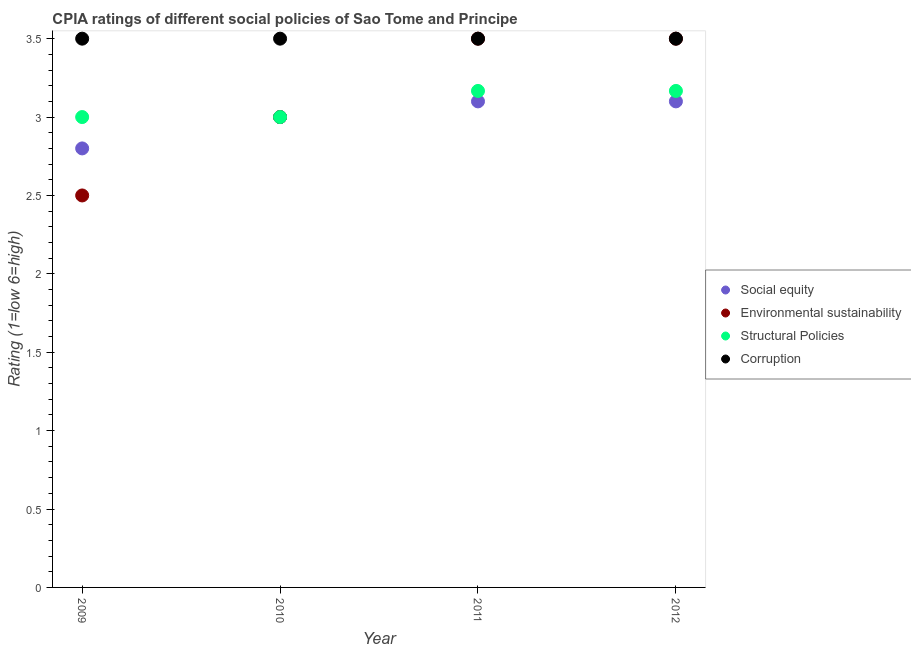How many different coloured dotlines are there?
Make the answer very short. 4. What is the cpia rating of structural policies in 2012?
Provide a succinct answer. 3.17. In which year was the cpia rating of corruption maximum?
Offer a terse response. 2009. In which year was the cpia rating of environmental sustainability minimum?
Ensure brevity in your answer.  2009. What is the total cpia rating of corruption in the graph?
Provide a short and direct response. 14. What is the difference between the cpia rating of environmental sustainability in 2010 and the cpia rating of corruption in 2009?
Make the answer very short. -0.5. What is the average cpia rating of structural policies per year?
Make the answer very short. 3.08. What is the ratio of the cpia rating of structural policies in 2010 to that in 2011?
Provide a short and direct response. 0.95. Is the difference between the cpia rating of social equity in 2009 and 2010 greater than the difference between the cpia rating of corruption in 2009 and 2010?
Ensure brevity in your answer.  No. Is the cpia rating of structural policies strictly less than the cpia rating of corruption over the years?
Keep it short and to the point. Yes. How many dotlines are there?
Give a very brief answer. 4. How many years are there in the graph?
Make the answer very short. 4. Are the values on the major ticks of Y-axis written in scientific E-notation?
Your response must be concise. No. Does the graph contain grids?
Ensure brevity in your answer.  No. What is the title of the graph?
Your answer should be very brief. CPIA ratings of different social policies of Sao Tome and Principe. Does "Debt policy" appear as one of the legend labels in the graph?
Provide a short and direct response. No. What is the Rating (1=low 6=high) of Social equity in 2009?
Give a very brief answer. 2.8. What is the Rating (1=low 6=high) in Environmental sustainability in 2009?
Offer a terse response. 2.5. What is the Rating (1=low 6=high) of Structural Policies in 2009?
Provide a short and direct response. 3. What is the Rating (1=low 6=high) of Corruption in 2009?
Offer a very short reply. 3.5. What is the Rating (1=low 6=high) in Social equity in 2010?
Your response must be concise. 3. What is the Rating (1=low 6=high) of Social equity in 2011?
Your answer should be compact. 3.1. What is the Rating (1=low 6=high) of Structural Policies in 2011?
Your answer should be very brief. 3.17. What is the Rating (1=low 6=high) of Structural Policies in 2012?
Your answer should be very brief. 3.17. Across all years, what is the maximum Rating (1=low 6=high) of Structural Policies?
Keep it short and to the point. 3.17. Across all years, what is the maximum Rating (1=low 6=high) in Corruption?
Make the answer very short. 3.5. Across all years, what is the minimum Rating (1=low 6=high) of Social equity?
Your answer should be very brief. 2.8. Across all years, what is the minimum Rating (1=low 6=high) in Environmental sustainability?
Give a very brief answer. 2.5. Across all years, what is the minimum Rating (1=low 6=high) of Structural Policies?
Make the answer very short. 3. What is the total Rating (1=low 6=high) in Structural Policies in the graph?
Offer a very short reply. 12.33. What is the total Rating (1=low 6=high) in Corruption in the graph?
Make the answer very short. 14. What is the difference between the Rating (1=low 6=high) in Social equity in 2009 and that in 2010?
Your answer should be compact. -0.2. What is the difference between the Rating (1=low 6=high) of Social equity in 2009 and that in 2011?
Your answer should be compact. -0.3. What is the difference between the Rating (1=low 6=high) of Environmental sustainability in 2009 and that in 2011?
Offer a very short reply. -1. What is the difference between the Rating (1=low 6=high) in Structural Policies in 2009 and that in 2011?
Offer a very short reply. -0.17. What is the difference between the Rating (1=low 6=high) in Social equity in 2009 and that in 2012?
Keep it short and to the point. -0.3. What is the difference between the Rating (1=low 6=high) of Environmental sustainability in 2010 and that in 2011?
Your answer should be very brief. -0.5. What is the difference between the Rating (1=low 6=high) in Social equity in 2010 and that in 2012?
Your answer should be compact. -0.1. What is the difference between the Rating (1=low 6=high) of Environmental sustainability in 2010 and that in 2012?
Your answer should be very brief. -0.5. What is the difference between the Rating (1=low 6=high) in Structural Policies in 2010 and that in 2012?
Make the answer very short. -0.17. What is the difference between the Rating (1=low 6=high) of Social equity in 2011 and that in 2012?
Offer a very short reply. 0. What is the difference between the Rating (1=low 6=high) of Structural Policies in 2011 and that in 2012?
Your response must be concise. 0. What is the difference between the Rating (1=low 6=high) of Social equity in 2009 and the Rating (1=low 6=high) of Corruption in 2010?
Your response must be concise. -0.7. What is the difference between the Rating (1=low 6=high) in Structural Policies in 2009 and the Rating (1=low 6=high) in Corruption in 2010?
Provide a succinct answer. -0.5. What is the difference between the Rating (1=low 6=high) of Social equity in 2009 and the Rating (1=low 6=high) of Structural Policies in 2011?
Ensure brevity in your answer.  -0.37. What is the difference between the Rating (1=low 6=high) of Environmental sustainability in 2009 and the Rating (1=low 6=high) of Structural Policies in 2011?
Your answer should be very brief. -0.67. What is the difference between the Rating (1=low 6=high) of Structural Policies in 2009 and the Rating (1=low 6=high) of Corruption in 2011?
Your answer should be very brief. -0.5. What is the difference between the Rating (1=low 6=high) of Social equity in 2009 and the Rating (1=low 6=high) of Structural Policies in 2012?
Your answer should be compact. -0.37. What is the difference between the Rating (1=low 6=high) in Structural Policies in 2009 and the Rating (1=low 6=high) in Corruption in 2012?
Keep it short and to the point. -0.5. What is the difference between the Rating (1=low 6=high) in Social equity in 2010 and the Rating (1=low 6=high) in Corruption in 2011?
Give a very brief answer. -0.5. What is the difference between the Rating (1=low 6=high) of Environmental sustainability in 2010 and the Rating (1=low 6=high) of Corruption in 2011?
Provide a succinct answer. -0.5. What is the difference between the Rating (1=low 6=high) in Structural Policies in 2010 and the Rating (1=low 6=high) in Corruption in 2011?
Ensure brevity in your answer.  -0.5. What is the difference between the Rating (1=low 6=high) of Social equity in 2010 and the Rating (1=low 6=high) of Environmental sustainability in 2012?
Keep it short and to the point. -0.5. What is the difference between the Rating (1=low 6=high) of Social equity in 2010 and the Rating (1=low 6=high) of Structural Policies in 2012?
Provide a short and direct response. -0.17. What is the difference between the Rating (1=low 6=high) of Social equity in 2010 and the Rating (1=low 6=high) of Corruption in 2012?
Provide a succinct answer. -0.5. What is the difference between the Rating (1=low 6=high) of Environmental sustainability in 2010 and the Rating (1=low 6=high) of Structural Policies in 2012?
Ensure brevity in your answer.  -0.17. What is the difference between the Rating (1=low 6=high) of Social equity in 2011 and the Rating (1=low 6=high) of Structural Policies in 2012?
Offer a terse response. -0.07. What is the difference between the Rating (1=low 6=high) in Social equity in 2011 and the Rating (1=low 6=high) in Corruption in 2012?
Your response must be concise. -0.4. What is the difference between the Rating (1=low 6=high) of Environmental sustainability in 2011 and the Rating (1=low 6=high) of Structural Policies in 2012?
Give a very brief answer. 0.33. What is the average Rating (1=low 6=high) in Environmental sustainability per year?
Make the answer very short. 3.12. What is the average Rating (1=low 6=high) in Structural Policies per year?
Offer a very short reply. 3.08. What is the average Rating (1=low 6=high) in Corruption per year?
Provide a short and direct response. 3.5. In the year 2009, what is the difference between the Rating (1=low 6=high) of Social equity and Rating (1=low 6=high) of Corruption?
Give a very brief answer. -0.7. In the year 2009, what is the difference between the Rating (1=low 6=high) in Environmental sustainability and Rating (1=low 6=high) in Structural Policies?
Provide a succinct answer. -0.5. In the year 2009, what is the difference between the Rating (1=low 6=high) of Environmental sustainability and Rating (1=low 6=high) of Corruption?
Offer a terse response. -1. In the year 2010, what is the difference between the Rating (1=low 6=high) of Social equity and Rating (1=low 6=high) of Environmental sustainability?
Make the answer very short. 0. In the year 2010, what is the difference between the Rating (1=low 6=high) in Environmental sustainability and Rating (1=low 6=high) in Structural Policies?
Make the answer very short. 0. In the year 2010, what is the difference between the Rating (1=low 6=high) of Structural Policies and Rating (1=low 6=high) of Corruption?
Make the answer very short. -0.5. In the year 2011, what is the difference between the Rating (1=low 6=high) in Social equity and Rating (1=low 6=high) in Structural Policies?
Your answer should be compact. -0.07. In the year 2011, what is the difference between the Rating (1=low 6=high) in Environmental sustainability and Rating (1=low 6=high) in Corruption?
Your response must be concise. 0. In the year 2011, what is the difference between the Rating (1=low 6=high) in Structural Policies and Rating (1=low 6=high) in Corruption?
Your answer should be compact. -0.33. In the year 2012, what is the difference between the Rating (1=low 6=high) in Social equity and Rating (1=low 6=high) in Environmental sustainability?
Offer a very short reply. -0.4. In the year 2012, what is the difference between the Rating (1=low 6=high) of Social equity and Rating (1=low 6=high) of Structural Policies?
Give a very brief answer. -0.07. In the year 2012, what is the difference between the Rating (1=low 6=high) in Environmental sustainability and Rating (1=low 6=high) in Structural Policies?
Offer a terse response. 0.33. In the year 2012, what is the difference between the Rating (1=low 6=high) in Structural Policies and Rating (1=low 6=high) in Corruption?
Offer a very short reply. -0.33. What is the ratio of the Rating (1=low 6=high) of Social equity in 2009 to that in 2010?
Your answer should be very brief. 0.93. What is the ratio of the Rating (1=low 6=high) of Social equity in 2009 to that in 2011?
Give a very brief answer. 0.9. What is the ratio of the Rating (1=low 6=high) in Environmental sustainability in 2009 to that in 2011?
Provide a short and direct response. 0.71. What is the ratio of the Rating (1=low 6=high) of Social equity in 2009 to that in 2012?
Provide a short and direct response. 0.9. What is the ratio of the Rating (1=low 6=high) in Structural Policies in 2009 to that in 2012?
Your response must be concise. 0.95. What is the ratio of the Rating (1=low 6=high) in Social equity in 2010 to that in 2011?
Offer a terse response. 0.97. What is the ratio of the Rating (1=low 6=high) of Environmental sustainability in 2010 to that in 2012?
Ensure brevity in your answer.  0.86. What is the ratio of the Rating (1=low 6=high) of Structural Policies in 2010 to that in 2012?
Provide a succinct answer. 0.95. What is the ratio of the Rating (1=low 6=high) of Corruption in 2010 to that in 2012?
Your answer should be compact. 1. What is the ratio of the Rating (1=low 6=high) in Social equity in 2011 to that in 2012?
Keep it short and to the point. 1. What is the ratio of the Rating (1=low 6=high) of Structural Policies in 2011 to that in 2012?
Offer a terse response. 1. What is the difference between the highest and the second highest Rating (1=low 6=high) in Environmental sustainability?
Your response must be concise. 0. What is the difference between the highest and the second highest Rating (1=low 6=high) in Corruption?
Offer a very short reply. 0. What is the difference between the highest and the lowest Rating (1=low 6=high) of Social equity?
Provide a short and direct response. 0.3. What is the difference between the highest and the lowest Rating (1=low 6=high) of Environmental sustainability?
Keep it short and to the point. 1. What is the difference between the highest and the lowest Rating (1=low 6=high) of Corruption?
Your answer should be very brief. 0. 